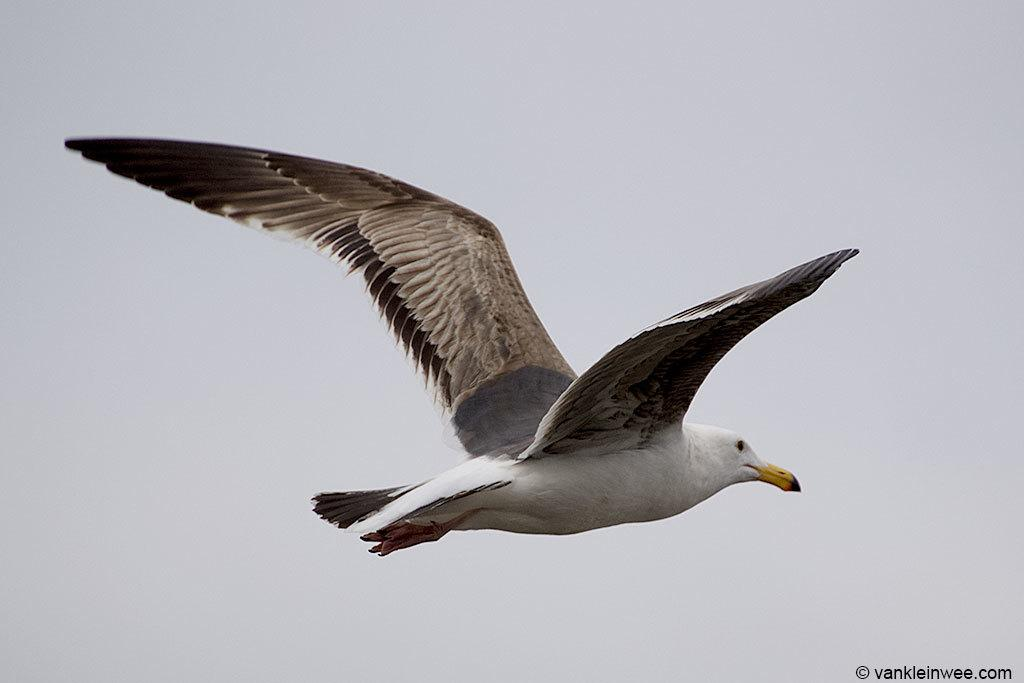What is the main subject of the image? There is a bird in the center of the image. Can you describe the bird in the image? The bird is the main subject, and it is located in the center of the image. What is the bird doing in the image? The provided facts do not mention any specific action or behavior of the bird. How many children are playing with the balloon in the image? There are no children or balloons present in the image; it only features a bird in the center. 